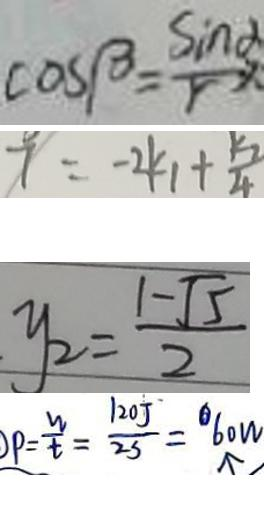Convert formula to latex. <formula><loc_0><loc_0><loc_500><loc_500>\cos \beta = \frac { \sin \alpha } { r } 
 7 = - 2 k _ { 1 } + \frac { k _ { 2 } } { 4 } 
 y _ { 2 } = \frac { 1 - \sqrt { 5 } } { 2 } 
 p = \frac { w } { t } = \frac { 1 2 0 J } { 2 s } = 6 0 w</formula> 